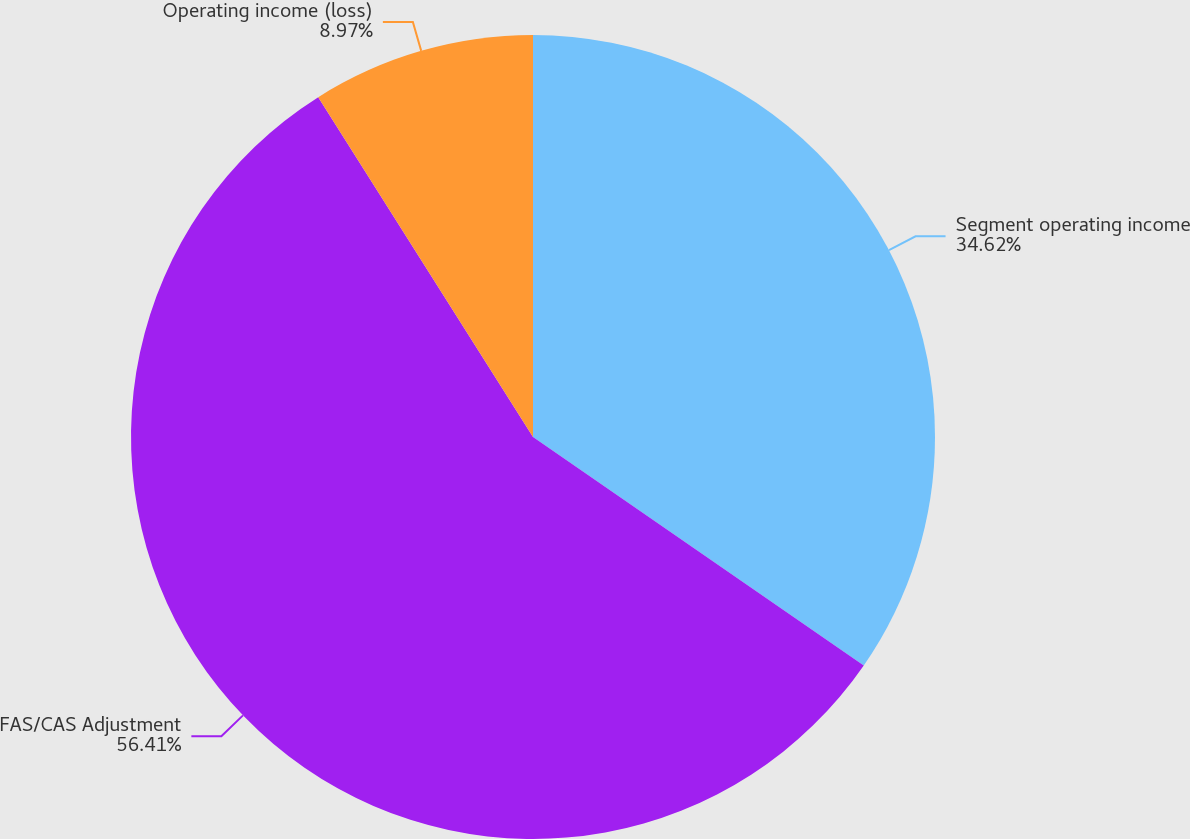<chart> <loc_0><loc_0><loc_500><loc_500><pie_chart><fcel>Segment operating income<fcel>FAS/CAS Adjustment<fcel>Operating income (loss)<nl><fcel>34.62%<fcel>56.41%<fcel>8.97%<nl></chart> 